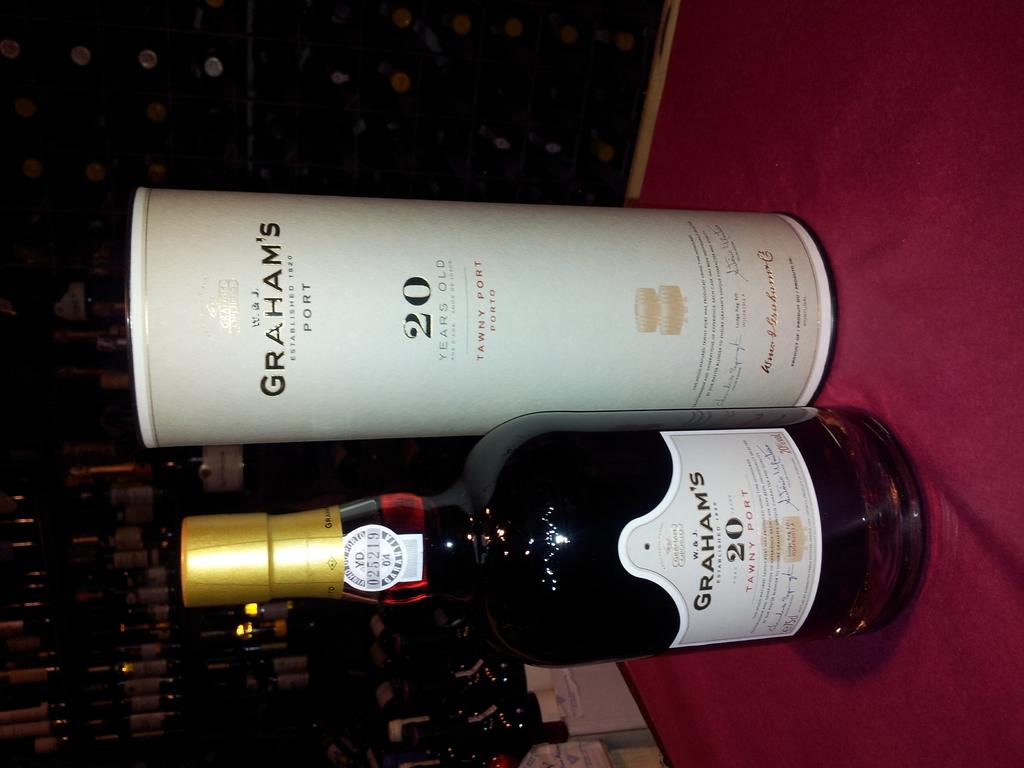How many years old is this wine?
Ensure brevity in your answer.  20. What is the logo on the bottle?
Offer a terse response. Grahams. 